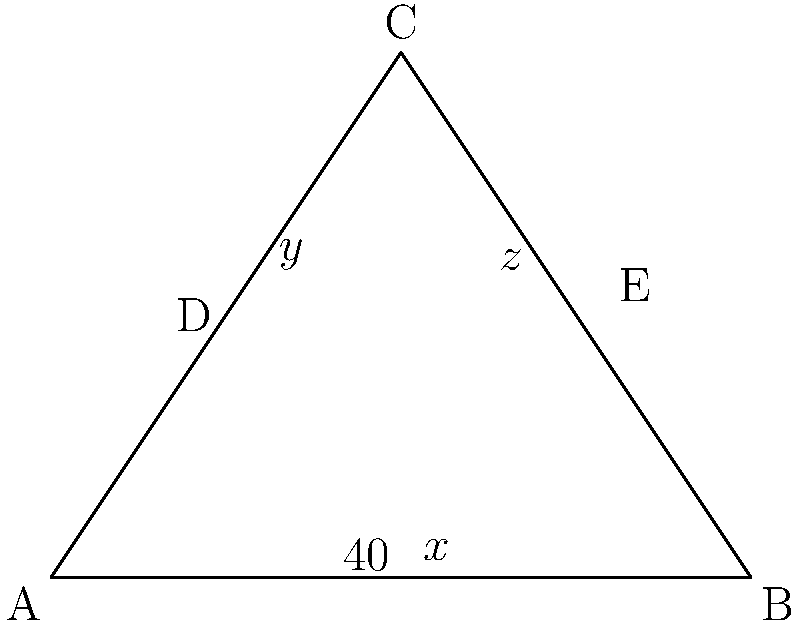In your decision tree for personal growth, the main branches form a triangle ABC, with additional sub-branches CD and CE. If angle BAC measures 40°, and angles ACD and BCE are denoted as y° and z° respectively, what is the value of x + y + z? Let's approach this step-by-step:

1) In triangle ABC, we know that the sum of all angles must be 180°.
   $\angle BAC + \angle ABC + \angle BCA = 180°$

2) We're given that $\angle BAC = 40°$, so:
   $40° + \angle ABC + \angle BCA = 180°$

3) The angle at the top of the triangle, $\angle BCA$, is split into three parts: y°, x°, and z°.
   So, $\angle BCA = y° + x° + z°$

4) Substituting this into our equation from step 2:
   $40° + \angle ABC + (y° + x° + z°) = 180°$

5) We don't know the value of $\angle ABC$, but we don't need to. We're only asked for the sum of x, y, and z.

6) Rearranging the equation:
   $y° + x° + z° = 180° - 40° - \angle ABC$
   $y° + x° + z° = 140° - \angle ABC$

7) Since $\angle ABC$ is positive (as all angles in a triangle are), $140° - \angle ABC$ must be less than 140°.

8) Therefore, the sum of x, y, and z must be exactly 140°.
Answer: 140° 